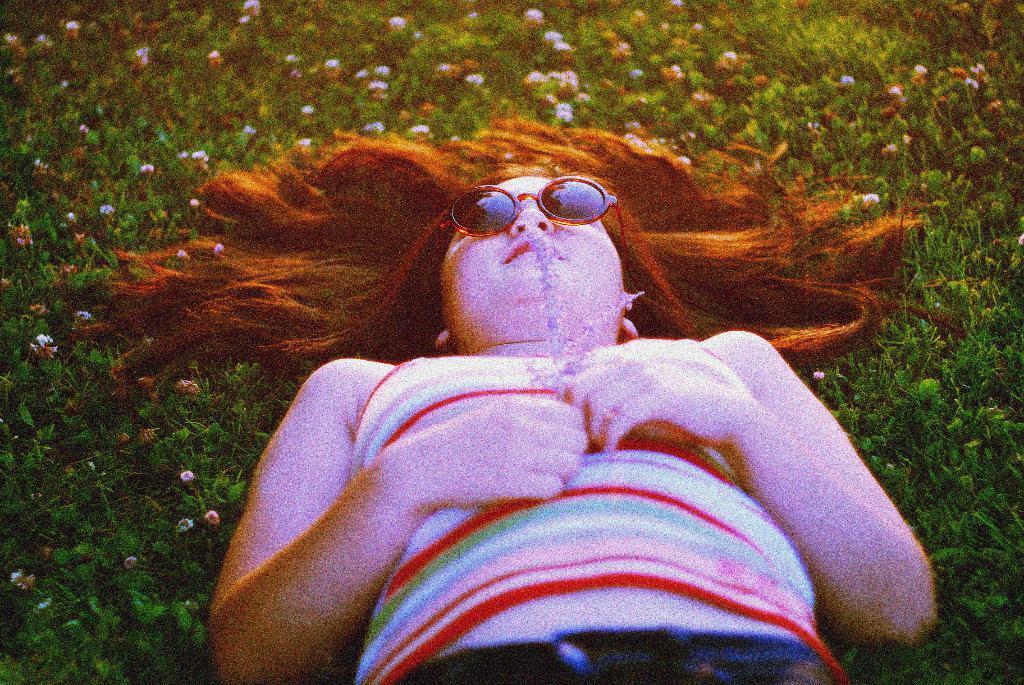Describe this image in one or two sentences. In this picture we can see a girl lying on the ground and in the background we can see grass, flowers. 